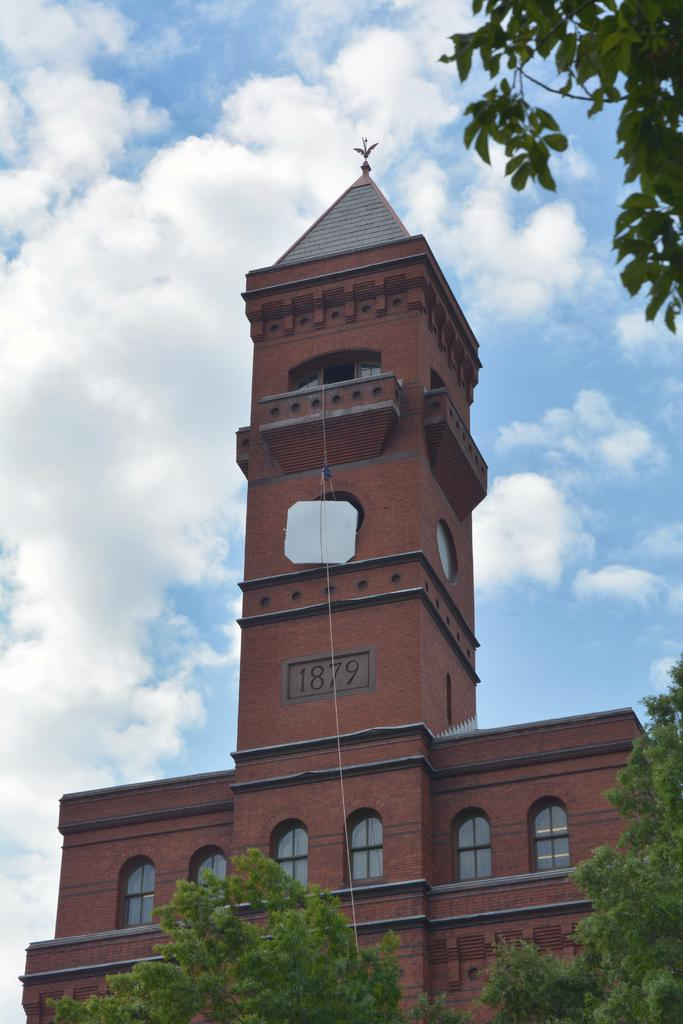What type of structure is visible in the image? There is a building in the image. What is the color of the building? The building is brown in color. What type of vegetation is present at the bottom of the image? There are trees at the bottom of the image. What is visible in the sky at the top of the image? There are clouds in the sky at the top of the image. How many insects are crawling on the building in the image? There are no insects visible on the building in the image. What type of pie is being served at the top of the building? There is no pie present in the image; it features a brown building, trees, and clouds in the sky. 